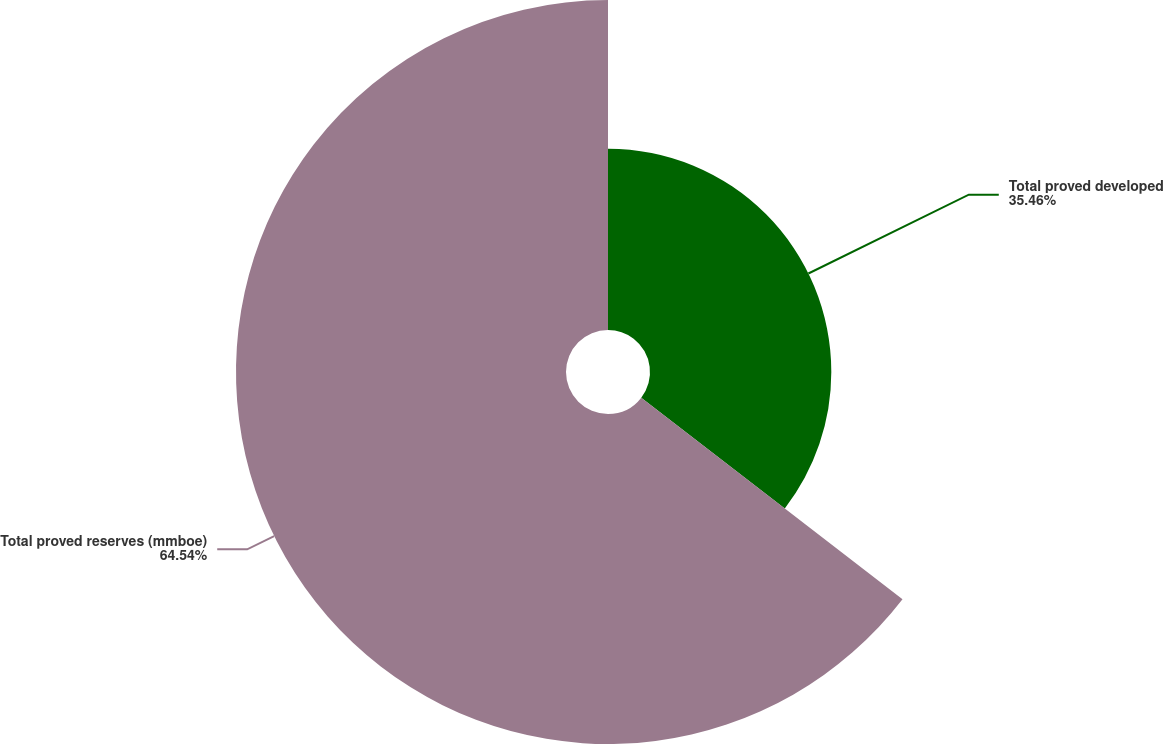Convert chart to OTSL. <chart><loc_0><loc_0><loc_500><loc_500><pie_chart><fcel>Total proved developed<fcel>Total proved reserves (mmboe)<nl><fcel>35.46%<fcel>64.54%<nl></chart> 